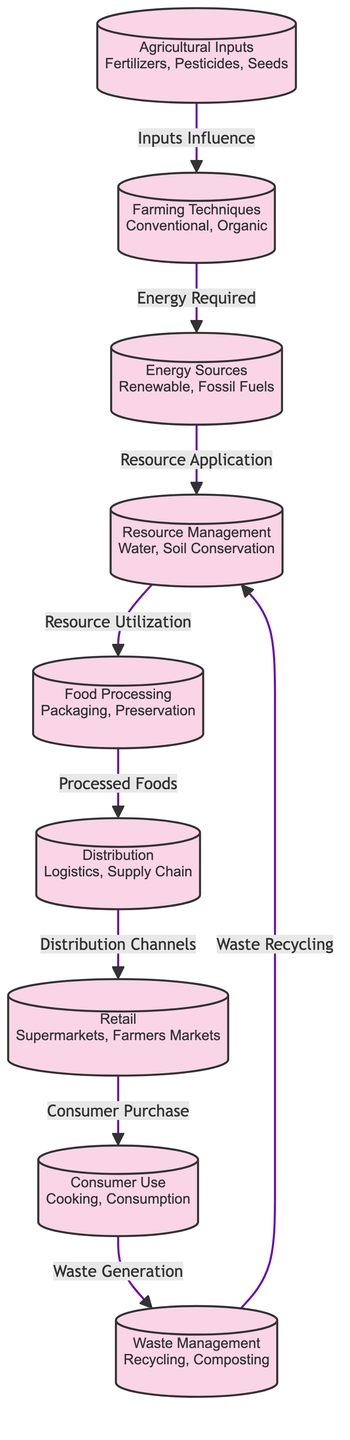What are the agricultural inputs listed in the diagram? The diagram identifies agricultural inputs as fertilizers, pesticides, and seeds, which are explicitly mentioned in the first node.
Answer: Fertilizers, Pesticides, Seeds How many nodes are there in the diagram? By counting the nodes from 1 to 9 in the diagram, we find that there are nine distinct nodes representing different stages in the food production chain.
Answer: 9 What is the relationship between Farming Techniques and Energy Sources? The diagram shows that farming techniques influence the energy required, represented by an edge pointing from the Farming Techniques node to the Energy Sources node.
Answer: Energy Required Which process follows Resource Management in the food chain? Resource management is followed by food processing, as indicated by the directed edge leading from Resource Management to Food Processing in the flow.
Answer: Food Processing What type of energy sources are mentioned in the diagram? The energy sources mentioned are renewable and fossil fuels, which are categorized under the Energy Sources node.
Answer: Renewable, Fossil Fuels How does Waste Management interact with Resource Management? The diagram illustrates a recycling connection from Waste Management back to Resource Management, indicating a cyclical relationship in resource conservation.
Answer: Waste Recycling What step occurs immediately after Distribution in the food chain? The immediate step after distribution is retail, as denoted by the edge leading from Distribution to Retail in the flow diagram.
Answer: Retail Which two nodes do Food Processing and Distribution connect to? Food processing connects to distribution, and distribution connects to retail, emphasizing the progression from one node to another through the food chain.
Answer: Distribution, Retail What role does Consumer Use play after Retail? Following retail, consumer use influences waste generation, as indicated by the directed edge from Consumer Use to Waste Management in the diagram.
Answer: Waste Generation 